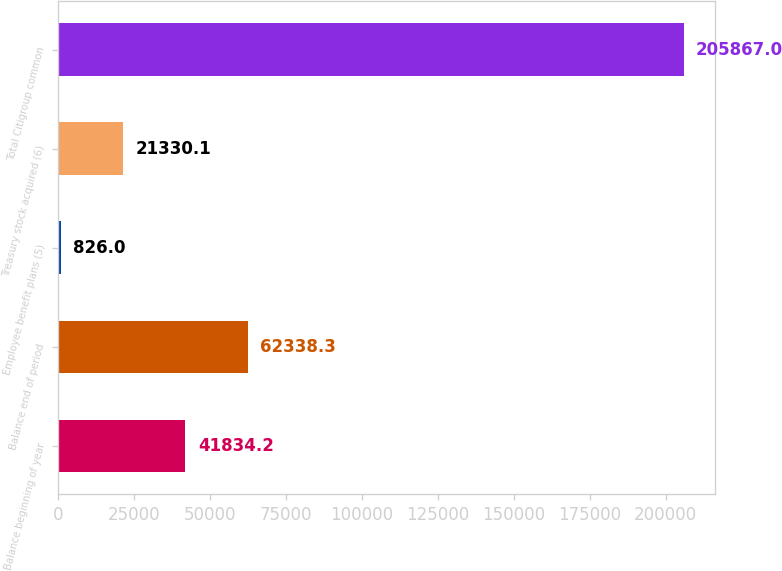Convert chart. <chart><loc_0><loc_0><loc_500><loc_500><bar_chart><fcel>Balance beginning of year<fcel>Balance end of period<fcel>Employee benefit plans (5)<fcel>Treasury stock acquired (6)<fcel>Total Citigroup common<nl><fcel>41834.2<fcel>62338.3<fcel>826<fcel>21330.1<fcel>205867<nl></chart> 